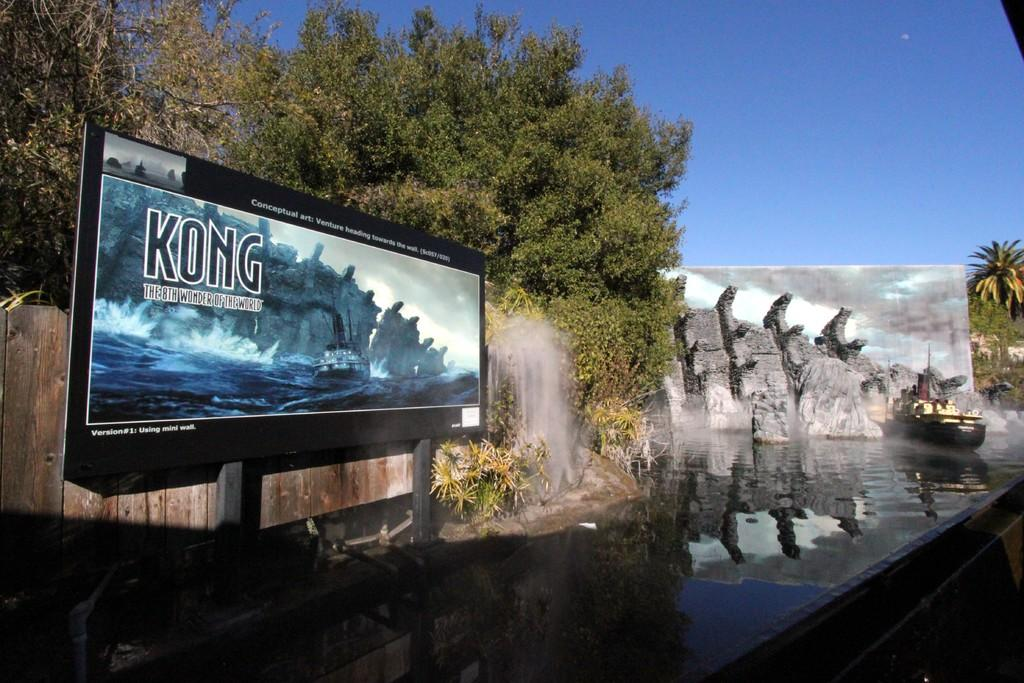<image>
Summarize the visual content of the image. A sign saying Kong the 8th wonder in the world 